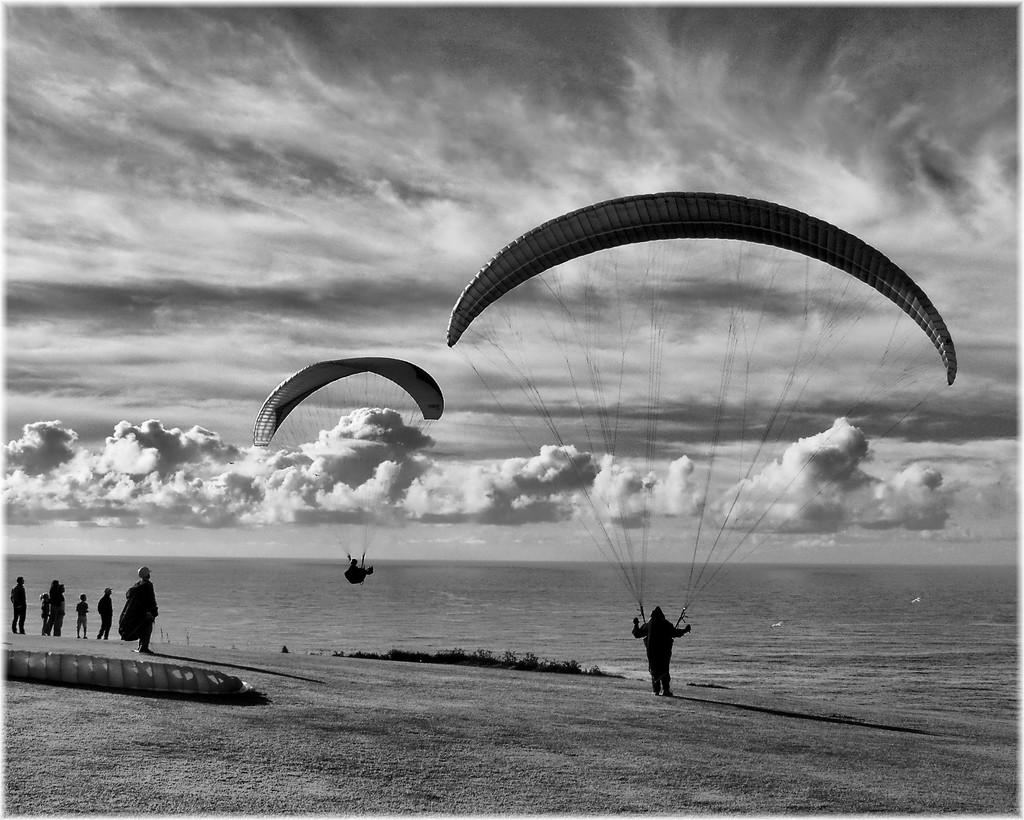What is the color scheme of the image? The image is black and white. What activity are the two persons engaged in? The two persons are paragliding in the image. What natural feature can be seen in the image? There is water visible in the image. What are the people near the water doing? The people near the water are not specified in the facts, but they are likely enjoying the water or the view. What is visible in the background of the image? The sky is visible in the background of the image, and there are clouds in the sky. How much profit did the paragliders make from their activity in the image? There is no information about profit or financial gain in the image, as it focuses on the activity of paragliding and the surrounding environment. 